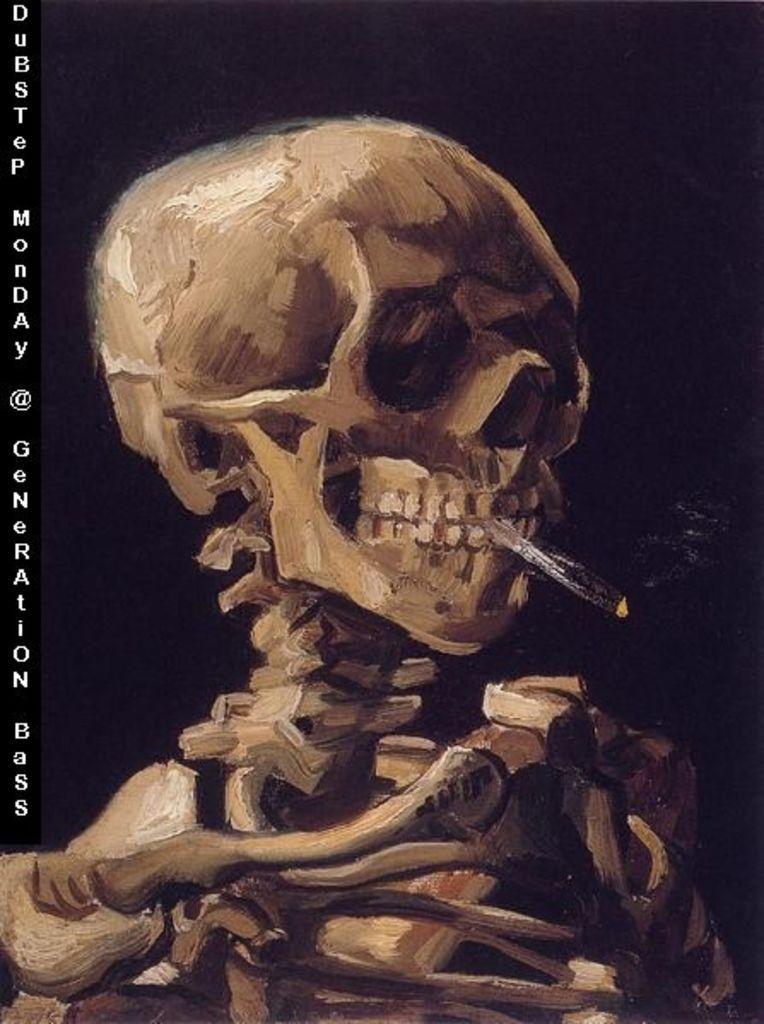In one or two sentences, can you explain what this image depicts? In this picture I can see the depiction of a skeleton and I see the watermark on the left side of this image and I see that it is dark in the background. 